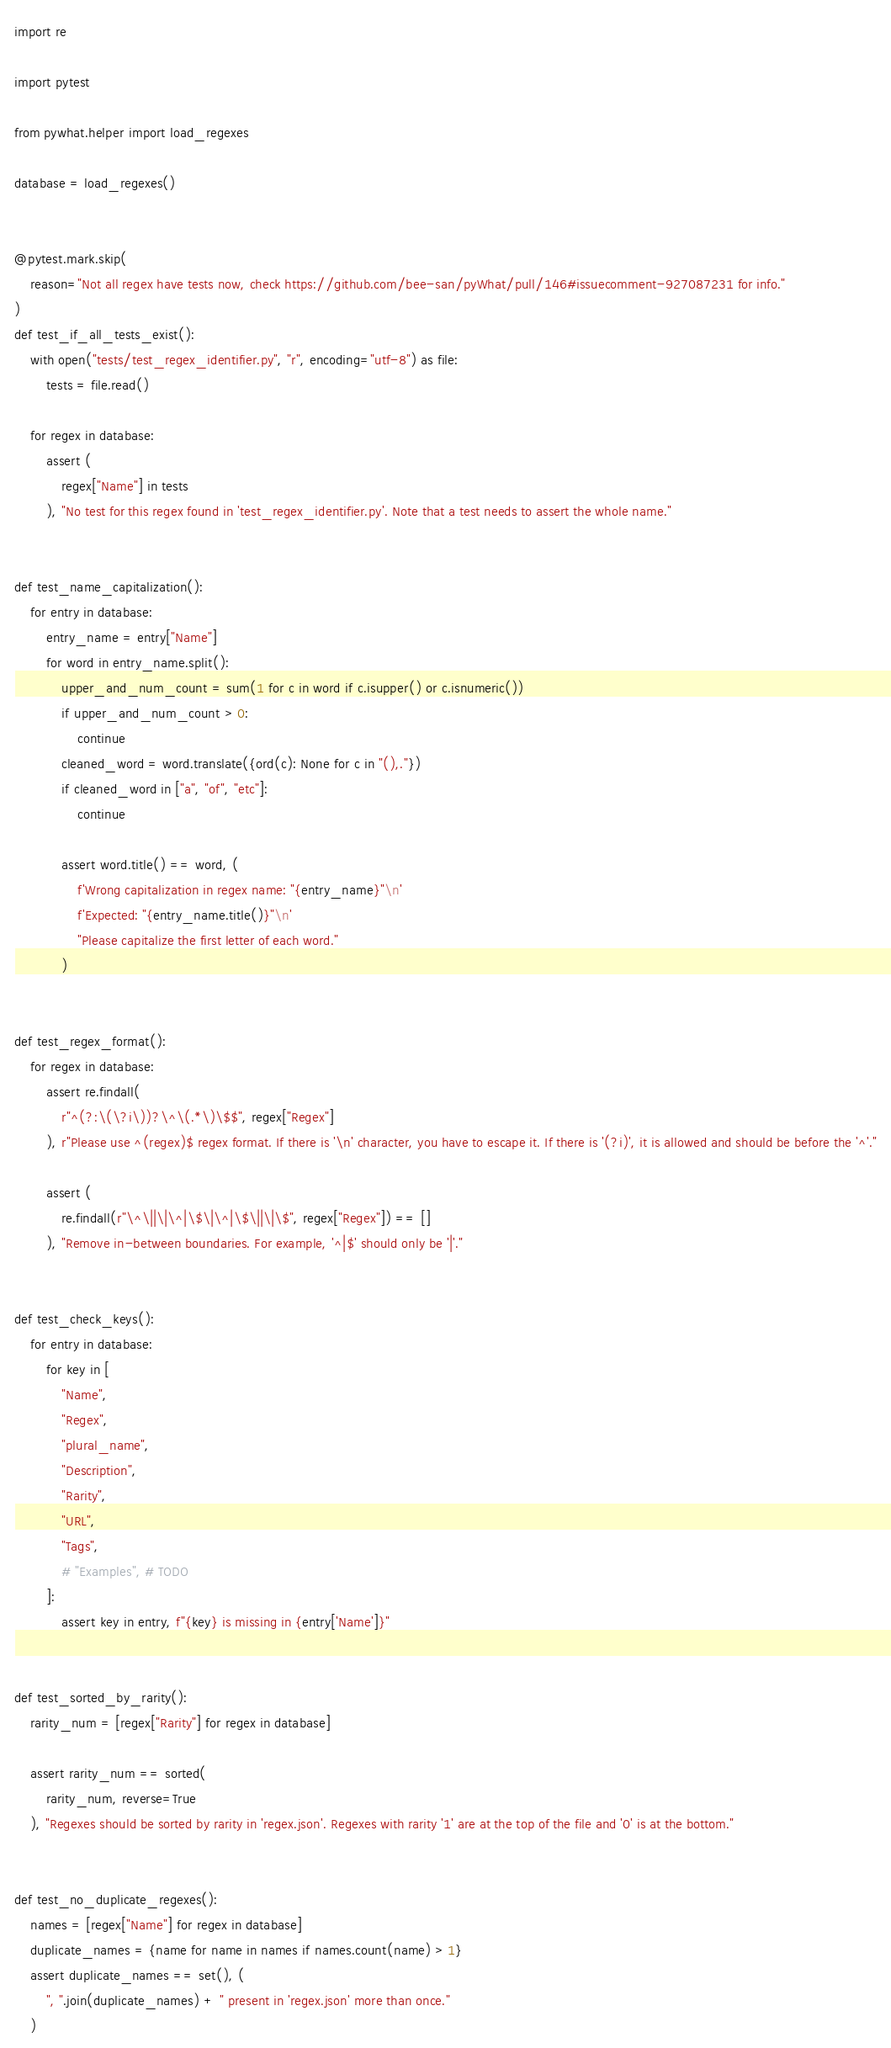Convert code to text. <code><loc_0><loc_0><loc_500><loc_500><_Python_>import re

import pytest

from pywhat.helper import load_regexes

database = load_regexes()


@pytest.mark.skip(
    reason="Not all regex have tests now, check https://github.com/bee-san/pyWhat/pull/146#issuecomment-927087231 for info."
)
def test_if_all_tests_exist():
    with open("tests/test_regex_identifier.py", "r", encoding="utf-8") as file:
        tests = file.read()

    for regex in database:
        assert (
            regex["Name"] in tests
        ), "No test for this regex found in 'test_regex_identifier.py'. Note that a test needs to assert the whole name."


def test_name_capitalization():
    for entry in database:
        entry_name = entry["Name"]
        for word in entry_name.split():
            upper_and_num_count = sum(1 for c in word if c.isupper() or c.isnumeric())
            if upper_and_num_count > 0:
                continue
            cleaned_word = word.translate({ord(c): None for c in "(),."})
            if cleaned_word in ["a", "of", "etc"]:
                continue

            assert word.title() == word, (
                f'Wrong capitalization in regex name: "{entry_name}"\n'
                f'Expected: "{entry_name.title()}"\n'
                "Please capitalize the first letter of each word."
            )


def test_regex_format():
    for regex in database:
        assert re.findall(
            r"^(?:\(\?i\))?\^\(.*\)\$$", regex["Regex"]
        ), r"Please use ^(regex)$ regex format. If there is '\n' character, you have to escape it. If there is '(?i)', it is allowed and should be before the '^'."

        assert (
            re.findall(r"\^\||\|\^|\$\|\^|\$\||\|\$", regex["Regex"]) == []
        ), "Remove in-between boundaries. For example, '^|$' should only be '|'."


def test_check_keys():
    for entry in database:
        for key in [
            "Name",
            "Regex",
            "plural_name",
            "Description",
            "Rarity",
            "URL",
            "Tags",
            # "Examples", # TODO
        ]:
            assert key in entry, f"{key} is missing in {entry['Name']}"


def test_sorted_by_rarity():
    rarity_num = [regex["Rarity"] for regex in database]

    assert rarity_num == sorted(
        rarity_num, reverse=True
    ), "Regexes should be sorted by rarity in 'regex.json'. Regexes with rarity '1' are at the top of the file and '0' is at the bottom."


def test_no_duplicate_regexes():
    names = [regex["Name"] for regex in database]
    duplicate_names = {name for name in names if names.count(name) > 1}
    assert duplicate_names == set(), (
        ", ".join(duplicate_names) + " present in 'regex.json' more than once."
    )
</code> 